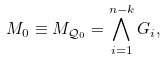<formula> <loc_0><loc_0><loc_500><loc_500>M _ { 0 } \equiv M _ { \mathcal { Q } _ { 0 } } = \bigwedge _ { i = 1 } ^ { n - k } { G _ { i } } ,</formula> 